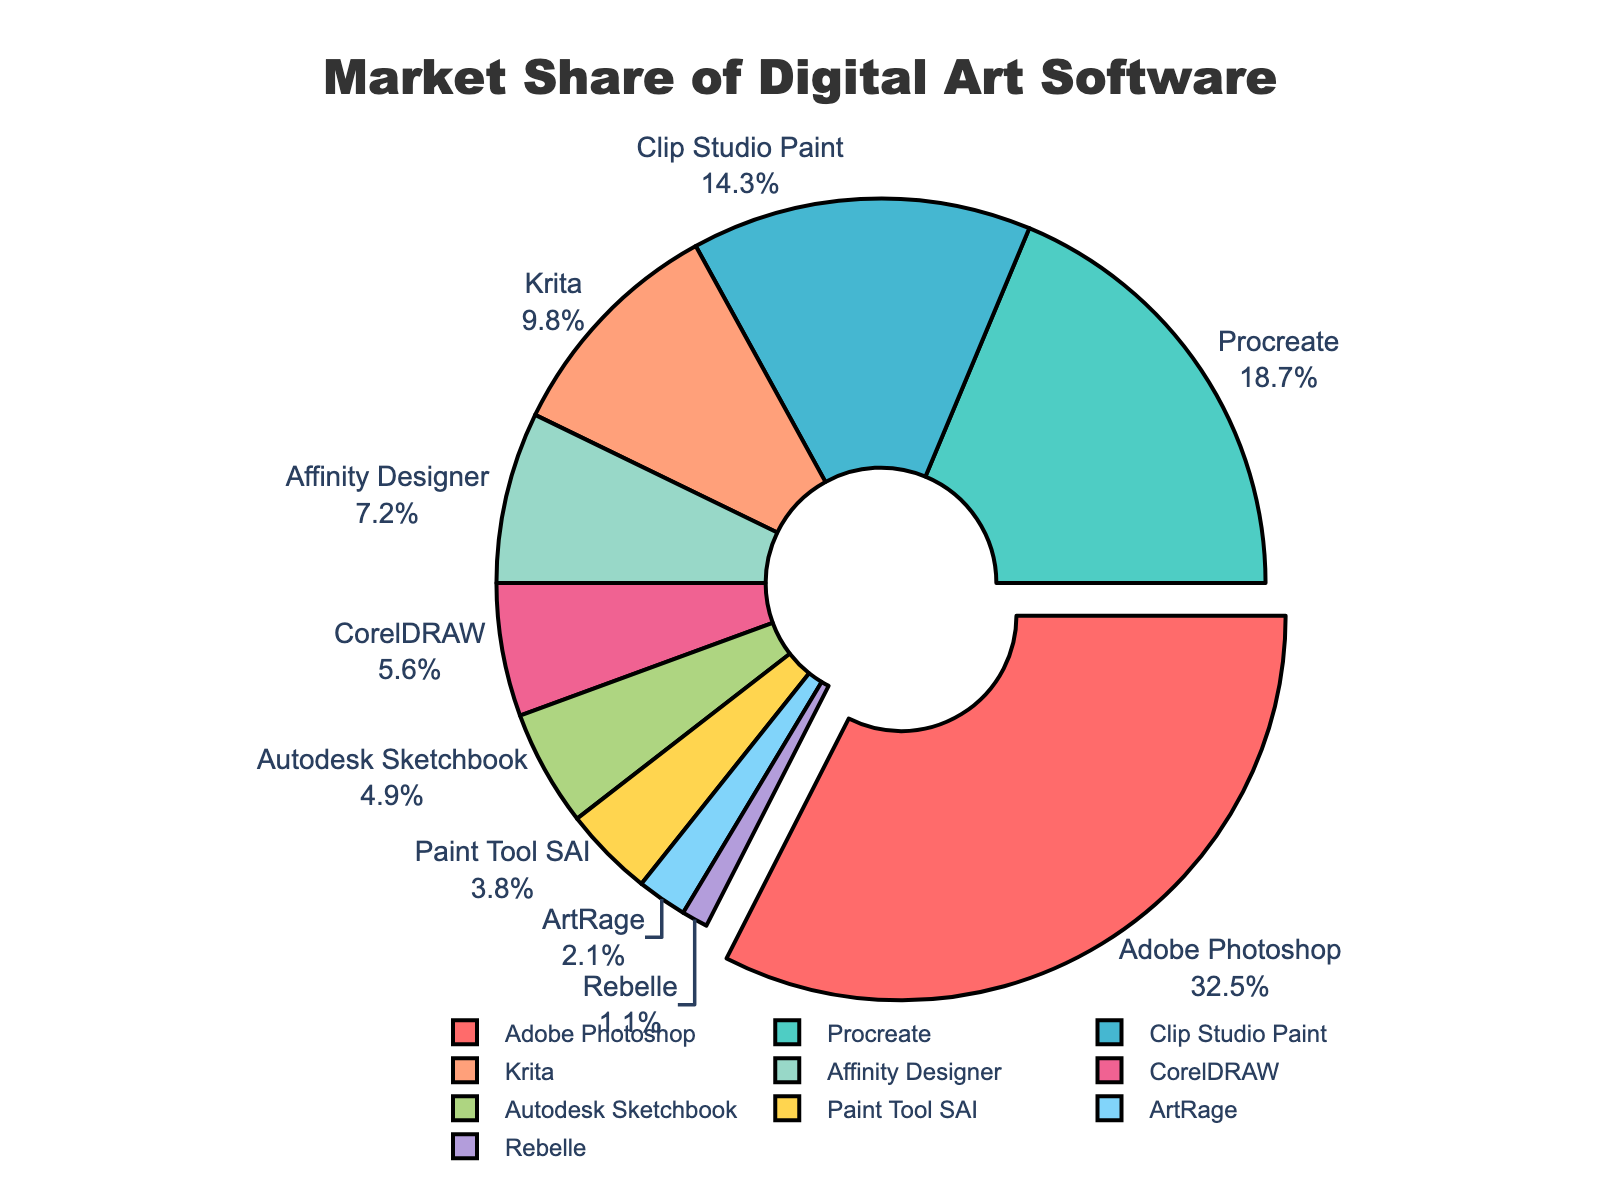Which software has the largest market share? The chart shows the market share distribution of various digital art software. The segment with the largest portion is labeled "Adobe Photoshop" and represents 32.5% of the market share.
Answer: Adobe Photoshop Which software has a market share greater than 15%? By observing the percentages indicated beside each segment, we can see that both Adobe Photoshop (32.5%) and Procreate (18.7%) have a market share greater than 15%.
Answer: Adobe Photoshop, Procreate How much more market share does Adobe Photoshop have compared to Krita? Adobe Photoshop has a market share of 32.5% and Krita has 9.8%. The difference is calculated as 32.5% - 9.8%
Answer: 22.7% What is the combined market share of Clip Studio Paint and Krita? To find the combined market share, we sum the market shares of Clip Studio Paint (14.3%) and Krita (9.8%). 14.3% + 9.8% = 24.1%
Answer: 24.1% Which software segment is pulled out from the pie chart? The segment that is visually pulled out from the chart, indicating it as the focal segment, is labeled "Adobe Photoshop."
Answer: Adobe Photoshop Rank the top three software by their market share. By examining the percentage values, the top three software are: Adobe Photoshop (32.5%), Procreate (18.7%), and Clip Studio Paint (14.3%).
Answer: Adobe Photoshop, Procreate, Clip Studio Paint Which software has the smallest market share? The segment with the smallest market share is labeled "Rebelle" at 1.1%, indicating it has the lowest percentage.
Answer: Rebelle What is the combined market share of Adobe Photoshop, Procreate, and Clip Studio Paint? We add the market shares of Adobe Photoshop (32.5%), Procreate (18.7%), and Clip Studio Paint (14.3%): 32.5% + 18.7% + 14.3% = 65.5%
Answer: 65.5% Which color represents CorelDRAW in the pie chart? By matching the colors and labels, CorelDRAW is represented by a distinctive green hue in the chart.
Answer: Green Which two software have similar market shares? Examining the percentages, Autodesk Sketchbook (4.9%) and Paint Tool SAI (3.8%) are relatively close to each other in market share.
Answer: Autodesk Sketchbook, Paint Tool SAI 